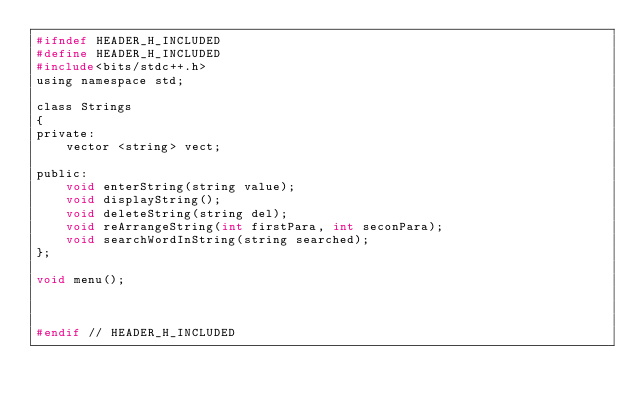Convert code to text. <code><loc_0><loc_0><loc_500><loc_500><_C_>#ifndef HEADER_H_INCLUDED
#define HEADER_H_INCLUDED
#include<bits/stdc++.h>
using namespace std;

class Strings
{
private:
    vector <string> vect;

public:
    void enterString(string value);
    void displayString();
    void deleteString(string del);
    void reArrangeString(int firstPara, int seconPara);
    void searchWordInString(string searched);
};

void menu();



#endif // HEADER_H_INCLUDED
</code> 